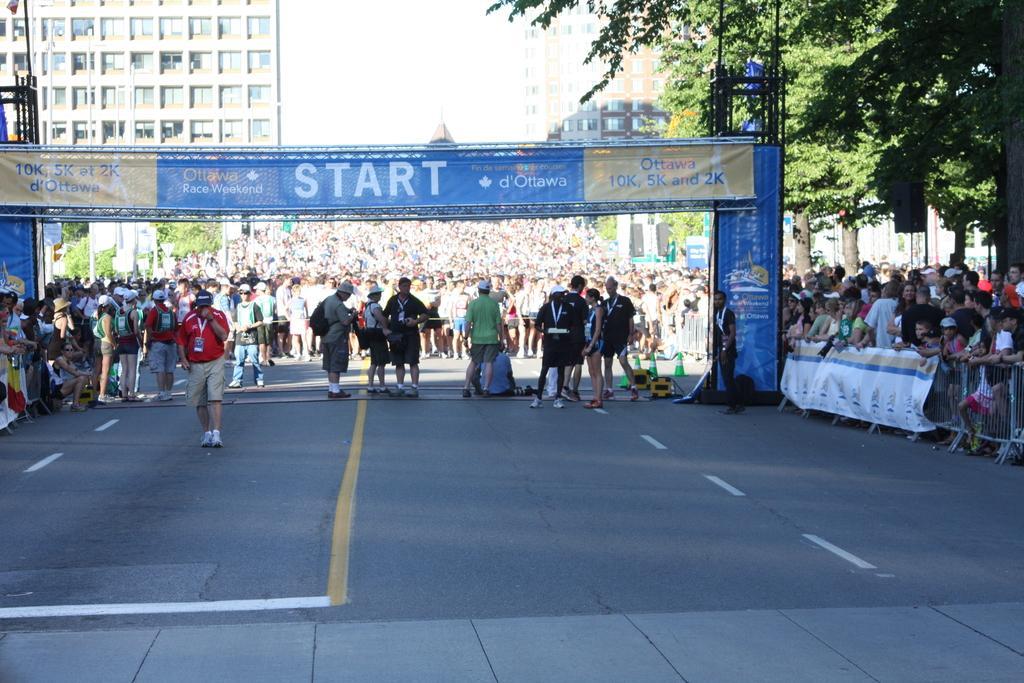In one or two sentences, can you explain what this image depicts? In this image we can see group of persons are standing on a road, in front there is a banner, there is a barricade, there is a tree, there are buildings, there is a sky. 